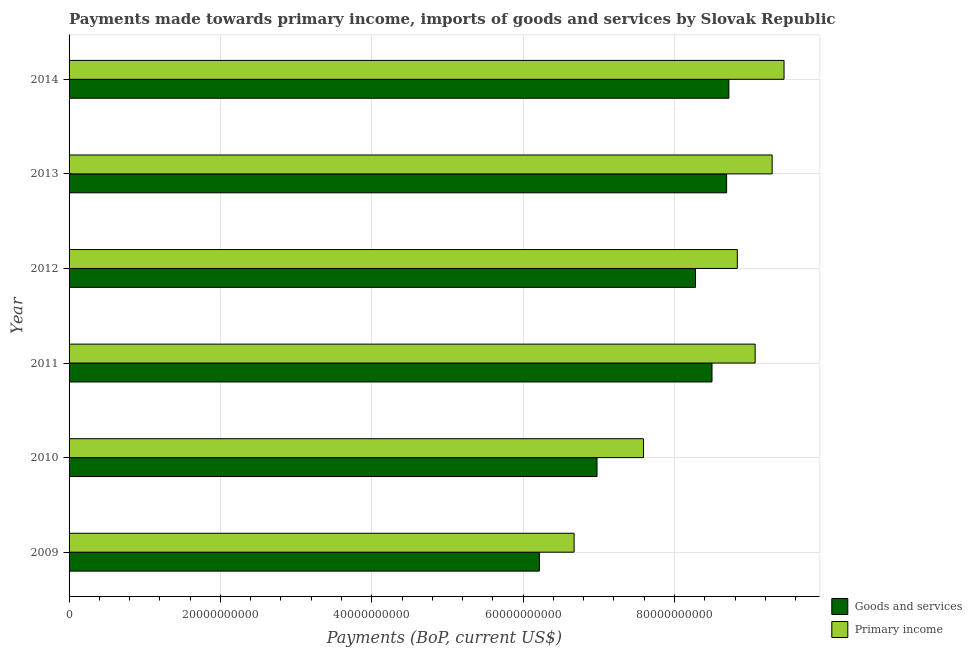How many groups of bars are there?
Keep it short and to the point. 6. How many bars are there on the 1st tick from the top?
Provide a short and direct response. 2. What is the payments made towards primary income in 2014?
Make the answer very short. 9.45e+1. Across all years, what is the maximum payments made towards primary income?
Make the answer very short. 9.45e+1. Across all years, what is the minimum payments made towards primary income?
Keep it short and to the point. 6.67e+1. In which year was the payments made towards goods and services minimum?
Your response must be concise. 2009. What is the total payments made towards goods and services in the graph?
Provide a short and direct response. 4.74e+11. What is the difference between the payments made towards primary income in 2011 and that in 2012?
Offer a very short reply. 2.35e+09. What is the difference between the payments made towards goods and services in 2010 and the payments made towards primary income in 2009?
Ensure brevity in your answer.  3.03e+09. What is the average payments made towards primary income per year?
Your answer should be very brief. 8.48e+1. In the year 2009, what is the difference between the payments made towards primary income and payments made towards goods and services?
Your answer should be very brief. 4.59e+09. In how many years, is the payments made towards primary income greater than 92000000000 US$?
Your answer should be compact. 2. What is the ratio of the payments made towards primary income in 2012 to that in 2013?
Give a very brief answer. 0.95. What is the difference between the highest and the second highest payments made towards goods and services?
Offer a terse response. 2.96e+08. What is the difference between the highest and the lowest payments made towards goods and services?
Provide a short and direct response. 2.50e+1. What does the 2nd bar from the top in 2013 represents?
Offer a terse response. Goods and services. What does the 1st bar from the bottom in 2009 represents?
Provide a succinct answer. Goods and services. Are all the bars in the graph horizontal?
Offer a very short reply. Yes. What is the difference between two consecutive major ticks on the X-axis?
Provide a succinct answer. 2.00e+1. Does the graph contain any zero values?
Your answer should be compact. No. Does the graph contain grids?
Your response must be concise. Yes. Where does the legend appear in the graph?
Offer a very short reply. Bottom right. What is the title of the graph?
Your response must be concise. Payments made towards primary income, imports of goods and services by Slovak Republic. What is the label or title of the X-axis?
Offer a very short reply. Payments (BoP, current US$). What is the label or title of the Y-axis?
Offer a terse response. Year. What is the Payments (BoP, current US$) in Goods and services in 2009?
Provide a short and direct response. 6.21e+1. What is the Payments (BoP, current US$) of Primary income in 2009?
Offer a terse response. 6.67e+1. What is the Payments (BoP, current US$) in Goods and services in 2010?
Ensure brevity in your answer.  6.98e+1. What is the Payments (BoP, current US$) in Primary income in 2010?
Your response must be concise. 7.59e+1. What is the Payments (BoP, current US$) in Goods and services in 2011?
Keep it short and to the point. 8.50e+1. What is the Payments (BoP, current US$) in Primary income in 2011?
Make the answer very short. 9.07e+1. What is the Payments (BoP, current US$) of Goods and services in 2012?
Your answer should be very brief. 8.28e+1. What is the Payments (BoP, current US$) of Primary income in 2012?
Give a very brief answer. 8.83e+1. What is the Payments (BoP, current US$) of Goods and services in 2013?
Your response must be concise. 8.69e+1. What is the Payments (BoP, current US$) in Primary income in 2013?
Your response must be concise. 9.29e+1. What is the Payments (BoP, current US$) of Goods and services in 2014?
Give a very brief answer. 8.72e+1. What is the Payments (BoP, current US$) of Primary income in 2014?
Ensure brevity in your answer.  9.45e+1. Across all years, what is the maximum Payments (BoP, current US$) in Goods and services?
Provide a short and direct response. 8.72e+1. Across all years, what is the maximum Payments (BoP, current US$) of Primary income?
Your response must be concise. 9.45e+1. Across all years, what is the minimum Payments (BoP, current US$) in Goods and services?
Your answer should be very brief. 6.21e+1. Across all years, what is the minimum Payments (BoP, current US$) in Primary income?
Your answer should be compact. 6.67e+1. What is the total Payments (BoP, current US$) in Goods and services in the graph?
Make the answer very short. 4.74e+11. What is the total Payments (BoP, current US$) in Primary income in the graph?
Offer a very short reply. 5.09e+11. What is the difference between the Payments (BoP, current US$) in Goods and services in 2009 and that in 2010?
Offer a terse response. -7.61e+09. What is the difference between the Payments (BoP, current US$) in Primary income in 2009 and that in 2010?
Ensure brevity in your answer.  -9.18e+09. What is the difference between the Payments (BoP, current US$) of Goods and services in 2009 and that in 2011?
Your response must be concise. -2.28e+1. What is the difference between the Payments (BoP, current US$) of Primary income in 2009 and that in 2011?
Keep it short and to the point. -2.39e+1. What is the difference between the Payments (BoP, current US$) in Goods and services in 2009 and that in 2012?
Offer a very short reply. -2.06e+1. What is the difference between the Payments (BoP, current US$) of Primary income in 2009 and that in 2012?
Keep it short and to the point. -2.16e+1. What is the difference between the Payments (BoP, current US$) of Goods and services in 2009 and that in 2013?
Ensure brevity in your answer.  -2.47e+1. What is the difference between the Payments (BoP, current US$) of Primary income in 2009 and that in 2013?
Offer a terse response. -2.62e+1. What is the difference between the Payments (BoP, current US$) of Goods and services in 2009 and that in 2014?
Keep it short and to the point. -2.50e+1. What is the difference between the Payments (BoP, current US$) in Primary income in 2009 and that in 2014?
Offer a very short reply. -2.77e+1. What is the difference between the Payments (BoP, current US$) in Goods and services in 2010 and that in 2011?
Offer a terse response. -1.52e+1. What is the difference between the Payments (BoP, current US$) of Primary income in 2010 and that in 2011?
Make the answer very short. -1.47e+1. What is the difference between the Payments (BoP, current US$) of Goods and services in 2010 and that in 2012?
Provide a succinct answer. -1.30e+1. What is the difference between the Payments (BoP, current US$) in Primary income in 2010 and that in 2012?
Ensure brevity in your answer.  -1.24e+1. What is the difference between the Payments (BoP, current US$) of Goods and services in 2010 and that in 2013?
Your answer should be very brief. -1.71e+1. What is the difference between the Payments (BoP, current US$) in Primary income in 2010 and that in 2013?
Give a very brief answer. -1.70e+1. What is the difference between the Payments (BoP, current US$) of Goods and services in 2010 and that in 2014?
Offer a very short reply. -1.74e+1. What is the difference between the Payments (BoP, current US$) of Primary income in 2010 and that in 2014?
Your answer should be very brief. -1.86e+1. What is the difference between the Payments (BoP, current US$) of Goods and services in 2011 and that in 2012?
Offer a very short reply. 2.18e+09. What is the difference between the Payments (BoP, current US$) in Primary income in 2011 and that in 2012?
Give a very brief answer. 2.35e+09. What is the difference between the Payments (BoP, current US$) in Goods and services in 2011 and that in 2013?
Your response must be concise. -1.93e+09. What is the difference between the Payments (BoP, current US$) of Primary income in 2011 and that in 2013?
Provide a succinct answer. -2.25e+09. What is the difference between the Payments (BoP, current US$) in Goods and services in 2011 and that in 2014?
Your answer should be very brief. -2.23e+09. What is the difference between the Payments (BoP, current US$) in Primary income in 2011 and that in 2014?
Give a very brief answer. -3.82e+09. What is the difference between the Payments (BoP, current US$) of Goods and services in 2012 and that in 2013?
Make the answer very short. -4.11e+09. What is the difference between the Payments (BoP, current US$) of Primary income in 2012 and that in 2013?
Ensure brevity in your answer.  -4.60e+09. What is the difference between the Payments (BoP, current US$) in Goods and services in 2012 and that in 2014?
Offer a terse response. -4.41e+09. What is the difference between the Payments (BoP, current US$) of Primary income in 2012 and that in 2014?
Provide a short and direct response. -6.17e+09. What is the difference between the Payments (BoP, current US$) in Goods and services in 2013 and that in 2014?
Your answer should be very brief. -2.96e+08. What is the difference between the Payments (BoP, current US$) in Primary income in 2013 and that in 2014?
Make the answer very short. -1.57e+09. What is the difference between the Payments (BoP, current US$) of Goods and services in 2009 and the Payments (BoP, current US$) of Primary income in 2010?
Offer a very short reply. -1.38e+1. What is the difference between the Payments (BoP, current US$) in Goods and services in 2009 and the Payments (BoP, current US$) in Primary income in 2011?
Ensure brevity in your answer.  -2.85e+1. What is the difference between the Payments (BoP, current US$) of Goods and services in 2009 and the Payments (BoP, current US$) of Primary income in 2012?
Make the answer very short. -2.62e+1. What is the difference between the Payments (BoP, current US$) in Goods and services in 2009 and the Payments (BoP, current US$) in Primary income in 2013?
Make the answer very short. -3.08e+1. What is the difference between the Payments (BoP, current US$) of Goods and services in 2009 and the Payments (BoP, current US$) of Primary income in 2014?
Ensure brevity in your answer.  -3.23e+1. What is the difference between the Payments (BoP, current US$) in Goods and services in 2010 and the Payments (BoP, current US$) in Primary income in 2011?
Your response must be concise. -2.09e+1. What is the difference between the Payments (BoP, current US$) in Goods and services in 2010 and the Payments (BoP, current US$) in Primary income in 2012?
Your response must be concise. -1.85e+1. What is the difference between the Payments (BoP, current US$) in Goods and services in 2010 and the Payments (BoP, current US$) in Primary income in 2013?
Ensure brevity in your answer.  -2.31e+1. What is the difference between the Payments (BoP, current US$) of Goods and services in 2010 and the Payments (BoP, current US$) of Primary income in 2014?
Your response must be concise. -2.47e+1. What is the difference between the Payments (BoP, current US$) of Goods and services in 2011 and the Payments (BoP, current US$) of Primary income in 2012?
Give a very brief answer. -3.35e+09. What is the difference between the Payments (BoP, current US$) of Goods and services in 2011 and the Payments (BoP, current US$) of Primary income in 2013?
Provide a short and direct response. -7.95e+09. What is the difference between the Payments (BoP, current US$) in Goods and services in 2011 and the Payments (BoP, current US$) in Primary income in 2014?
Ensure brevity in your answer.  -9.52e+09. What is the difference between the Payments (BoP, current US$) of Goods and services in 2012 and the Payments (BoP, current US$) of Primary income in 2013?
Your response must be concise. -1.01e+1. What is the difference between the Payments (BoP, current US$) of Goods and services in 2012 and the Payments (BoP, current US$) of Primary income in 2014?
Make the answer very short. -1.17e+1. What is the difference between the Payments (BoP, current US$) of Goods and services in 2013 and the Payments (BoP, current US$) of Primary income in 2014?
Offer a terse response. -7.59e+09. What is the average Payments (BoP, current US$) of Goods and services per year?
Make the answer very short. 7.90e+1. What is the average Payments (BoP, current US$) in Primary income per year?
Offer a terse response. 8.48e+1. In the year 2009, what is the difference between the Payments (BoP, current US$) in Goods and services and Payments (BoP, current US$) in Primary income?
Offer a very short reply. -4.59e+09. In the year 2010, what is the difference between the Payments (BoP, current US$) of Goods and services and Payments (BoP, current US$) of Primary income?
Provide a succinct answer. -6.15e+09. In the year 2011, what is the difference between the Payments (BoP, current US$) of Goods and services and Payments (BoP, current US$) of Primary income?
Offer a very short reply. -5.70e+09. In the year 2012, what is the difference between the Payments (BoP, current US$) of Goods and services and Payments (BoP, current US$) of Primary income?
Ensure brevity in your answer.  -5.53e+09. In the year 2013, what is the difference between the Payments (BoP, current US$) of Goods and services and Payments (BoP, current US$) of Primary income?
Give a very brief answer. -6.01e+09. In the year 2014, what is the difference between the Payments (BoP, current US$) in Goods and services and Payments (BoP, current US$) in Primary income?
Your answer should be very brief. -7.29e+09. What is the ratio of the Payments (BoP, current US$) of Goods and services in 2009 to that in 2010?
Your answer should be very brief. 0.89. What is the ratio of the Payments (BoP, current US$) in Primary income in 2009 to that in 2010?
Ensure brevity in your answer.  0.88. What is the ratio of the Payments (BoP, current US$) of Goods and services in 2009 to that in 2011?
Offer a very short reply. 0.73. What is the ratio of the Payments (BoP, current US$) in Primary income in 2009 to that in 2011?
Your answer should be very brief. 0.74. What is the ratio of the Payments (BoP, current US$) of Goods and services in 2009 to that in 2012?
Provide a short and direct response. 0.75. What is the ratio of the Payments (BoP, current US$) of Primary income in 2009 to that in 2012?
Offer a terse response. 0.76. What is the ratio of the Payments (BoP, current US$) in Goods and services in 2009 to that in 2013?
Ensure brevity in your answer.  0.72. What is the ratio of the Payments (BoP, current US$) of Primary income in 2009 to that in 2013?
Provide a succinct answer. 0.72. What is the ratio of the Payments (BoP, current US$) of Goods and services in 2009 to that in 2014?
Offer a very short reply. 0.71. What is the ratio of the Payments (BoP, current US$) in Primary income in 2009 to that in 2014?
Give a very brief answer. 0.71. What is the ratio of the Payments (BoP, current US$) of Goods and services in 2010 to that in 2011?
Offer a very short reply. 0.82. What is the ratio of the Payments (BoP, current US$) in Primary income in 2010 to that in 2011?
Keep it short and to the point. 0.84. What is the ratio of the Payments (BoP, current US$) of Goods and services in 2010 to that in 2012?
Make the answer very short. 0.84. What is the ratio of the Payments (BoP, current US$) of Primary income in 2010 to that in 2012?
Your answer should be compact. 0.86. What is the ratio of the Payments (BoP, current US$) of Goods and services in 2010 to that in 2013?
Offer a very short reply. 0.8. What is the ratio of the Payments (BoP, current US$) in Primary income in 2010 to that in 2013?
Provide a short and direct response. 0.82. What is the ratio of the Payments (BoP, current US$) in Goods and services in 2010 to that in 2014?
Make the answer very short. 0.8. What is the ratio of the Payments (BoP, current US$) in Primary income in 2010 to that in 2014?
Ensure brevity in your answer.  0.8. What is the ratio of the Payments (BoP, current US$) in Goods and services in 2011 to that in 2012?
Provide a short and direct response. 1.03. What is the ratio of the Payments (BoP, current US$) of Primary income in 2011 to that in 2012?
Your answer should be compact. 1.03. What is the ratio of the Payments (BoP, current US$) in Goods and services in 2011 to that in 2013?
Ensure brevity in your answer.  0.98. What is the ratio of the Payments (BoP, current US$) of Primary income in 2011 to that in 2013?
Give a very brief answer. 0.98. What is the ratio of the Payments (BoP, current US$) of Goods and services in 2011 to that in 2014?
Provide a short and direct response. 0.97. What is the ratio of the Payments (BoP, current US$) of Primary income in 2011 to that in 2014?
Provide a succinct answer. 0.96. What is the ratio of the Payments (BoP, current US$) of Goods and services in 2012 to that in 2013?
Keep it short and to the point. 0.95. What is the ratio of the Payments (BoP, current US$) in Primary income in 2012 to that in 2013?
Offer a very short reply. 0.95. What is the ratio of the Payments (BoP, current US$) in Goods and services in 2012 to that in 2014?
Provide a short and direct response. 0.95. What is the ratio of the Payments (BoP, current US$) in Primary income in 2012 to that in 2014?
Provide a short and direct response. 0.93. What is the ratio of the Payments (BoP, current US$) of Primary income in 2013 to that in 2014?
Give a very brief answer. 0.98. What is the difference between the highest and the second highest Payments (BoP, current US$) of Goods and services?
Offer a terse response. 2.96e+08. What is the difference between the highest and the second highest Payments (BoP, current US$) of Primary income?
Ensure brevity in your answer.  1.57e+09. What is the difference between the highest and the lowest Payments (BoP, current US$) of Goods and services?
Offer a very short reply. 2.50e+1. What is the difference between the highest and the lowest Payments (BoP, current US$) of Primary income?
Provide a short and direct response. 2.77e+1. 